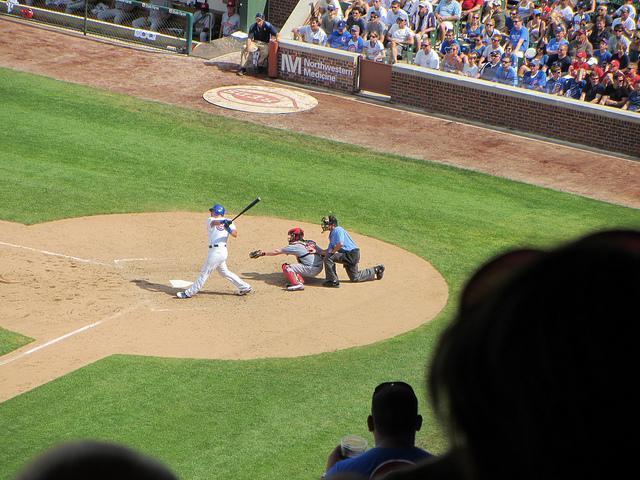How many people are there?
Give a very brief answer. 5. How many bear arms are raised to the bears' ears?
Give a very brief answer. 0. 